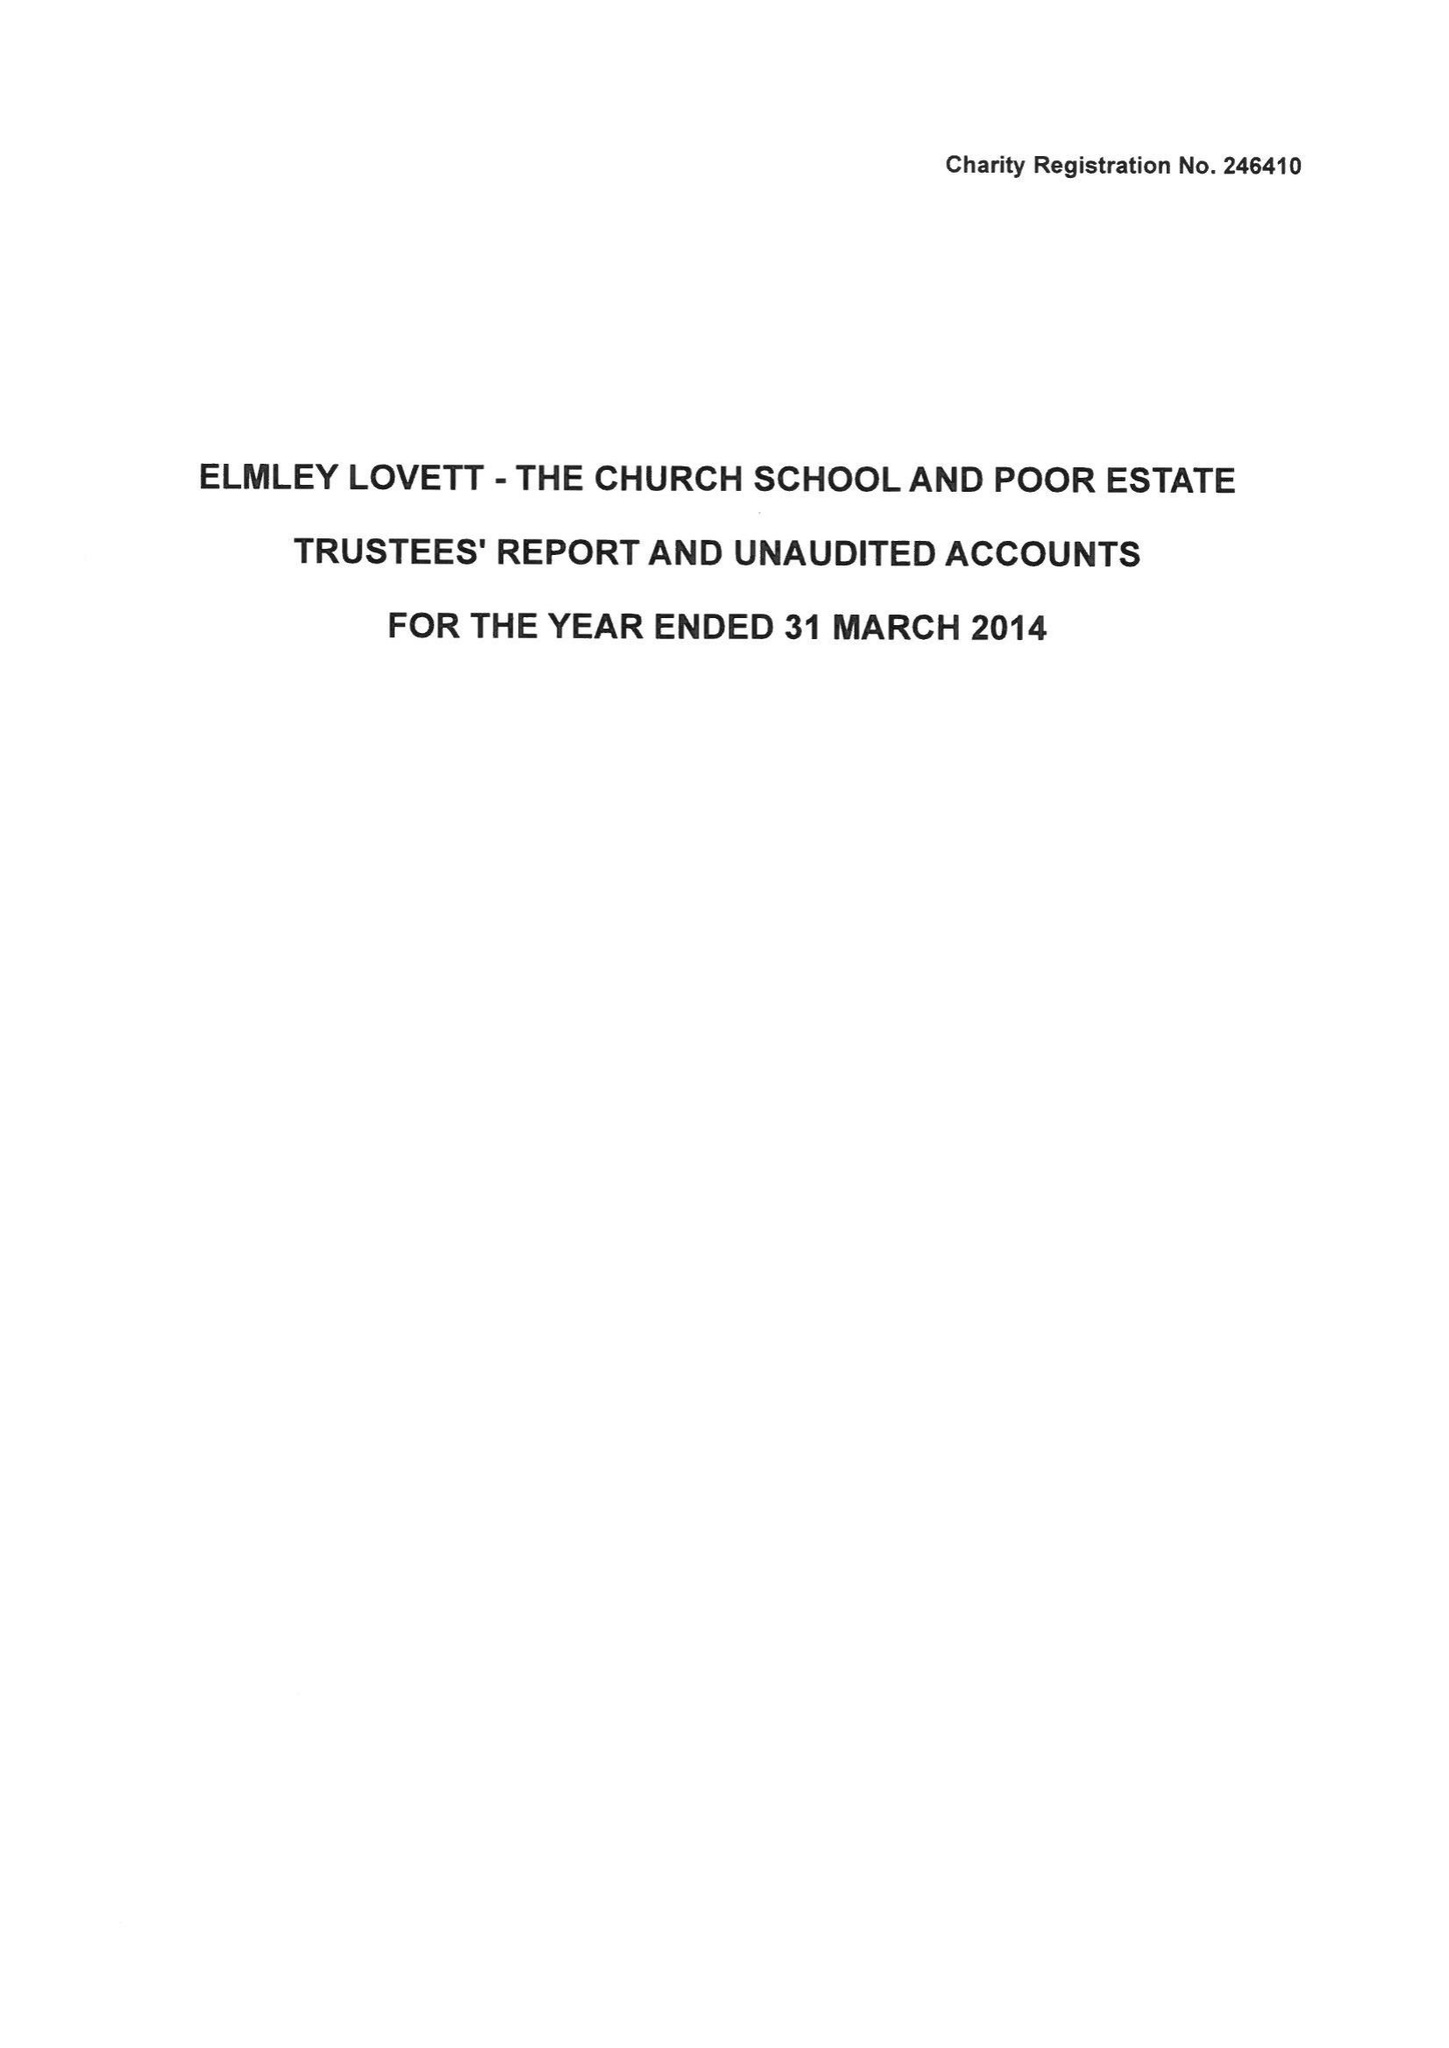What is the value for the income_annually_in_british_pounds?
Answer the question using a single word or phrase. 69084.00 